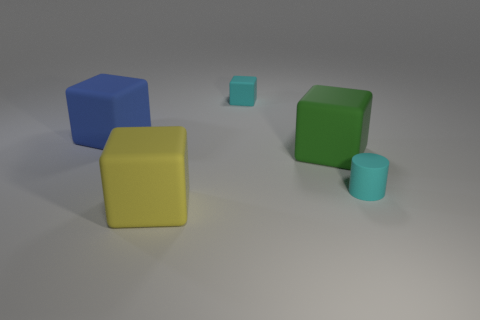What number of big blue cubes are there?
Keep it short and to the point. 1. There is a small matte cylinder; how many matte cylinders are in front of it?
Your answer should be very brief. 0. Are the blue block and the tiny cylinder made of the same material?
Offer a very short reply. Yes. How many things are left of the cyan cylinder and right of the cyan cube?
Your response must be concise. 1. How many other objects are the same color as the cylinder?
Your response must be concise. 1. What number of blue objects are either rubber things or matte cylinders?
Offer a very short reply. 1. The yellow block is what size?
Ensure brevity in your answer.  Large. How many matte objects are either big blue blocks or green blocks?
Keep it short and to the point. 2. Is the number of rubber cylinders less than the number of brown matte balls?
Provide a succinct answer. No. How many other objects are the same material as the big green object?
Provide a succinct answer. 4. 